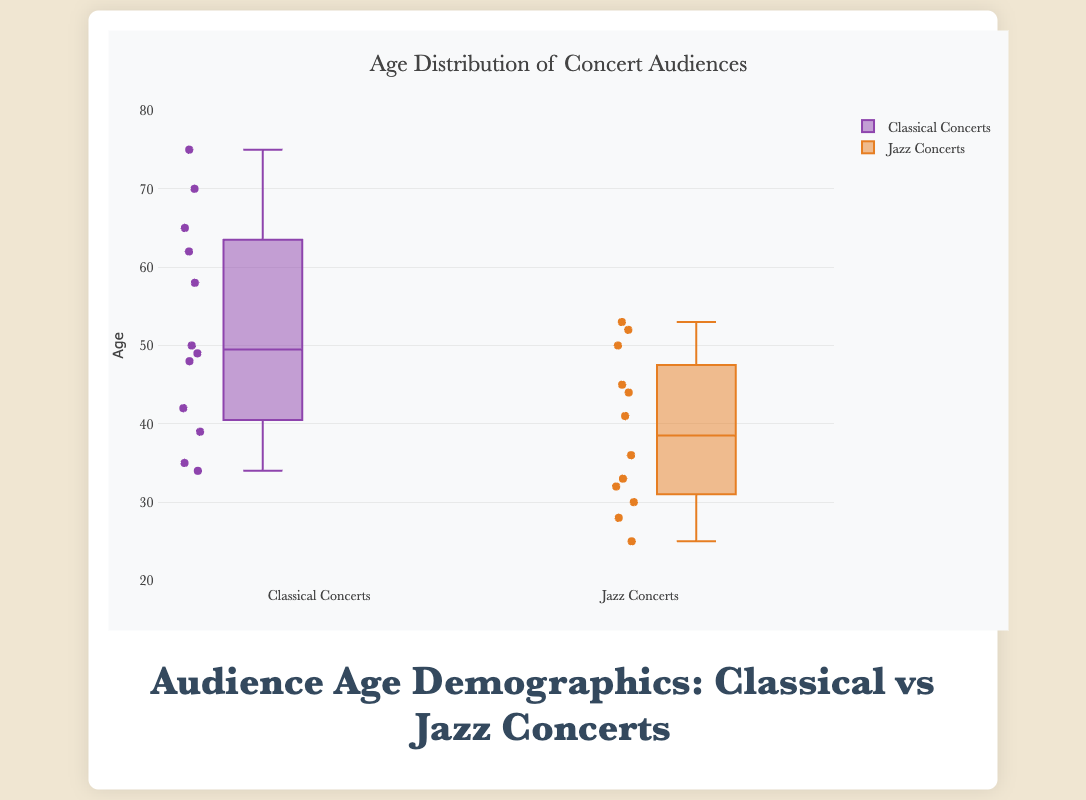How many data points are there for Classical Concerts? Count the number of data points in the Classical Concerts box plot. Referring to the data provided, we see 12 entries for Classical Concerts.
Answer: 12 How many data points are plotted for Jazz Concerts? Count the number of data points in the Jazz Concerts box plot. Referring to the data provided, we see 12 entries for Jazz Concerts.
Answer: 12 What is the title of the figure? Read the title at the top of the chart. It specifies the theme of the figure. The title in the HTML code is "Audience Age Demographics: Classical vs Jazz Concerts."
Answer: Audience Age Demographics: Classical vs Jazz Concerts What is the median age for the Classical Concert audience? Find the middle value in the Classical Concert box plot. For this, organize all ages and locate the median value. The ages for Classical are: [34, 35, 39, 42, 48, 49, 50, 58, 62, 65, 70, 75], so the median is the average of the 6th and 7th values. (49 + 50)/2 = 49.5
Answer: 49.5 What is the median age for the Jazz Concert audience? Find the middle value in the Jazz Concert box plot. The ages for Jazz are: [25, 28, 30, 32, 33, 36, 41, 44, 45, 50, 52, 53]. The median is the average of the 6th and 7th values. (36 + 41)/2 = 38.5
Answer: 38.5 Which genre has a higher median audience age? Compare the median ages of both Classical and Jazz concerts. The median age for Classical is 49.5, and for Jazz, it is 38.5.
Answer: Classical What is the interquartile range (IQR) of ages for Classical Concerts? The IQR is calculated as the difference between the third quartile (Q3) and the first quartile (Q1). For Classical concerts, Q1 (25th percentile): 39, Q3 (75th percentile): 62. IQR = Q3 - Q1 = 62 - 39 = 23
Answer: 23 What is the interquartile range (IQR) of ages for Jazz Concerts? The IQR for Jazz concerts is calculated as Q3 - Q1. Q1 value (25th percentile): 30, Q3 value (75th percentile): 50. IQR = 50 - 30 = 20
Answer: 20 What is the age range for the audience at Jazz Concerts? The range is the difference between the maximum and minimum ages in the Jazz data. Min age: 25, Max age: 53. Range = 53 - 25 = 28
Answer: 28 What are the lower and upper whiskers of the Classical Concerts age distribution? The lower whisker and upper whisker represent the smallest and largest values within 1.5 times the IQR from the first and third quartiles, respectively. Here, the values are given directly as the minimum (34) and maximum (75) ages observed in data.
Answer: 34 and 75 